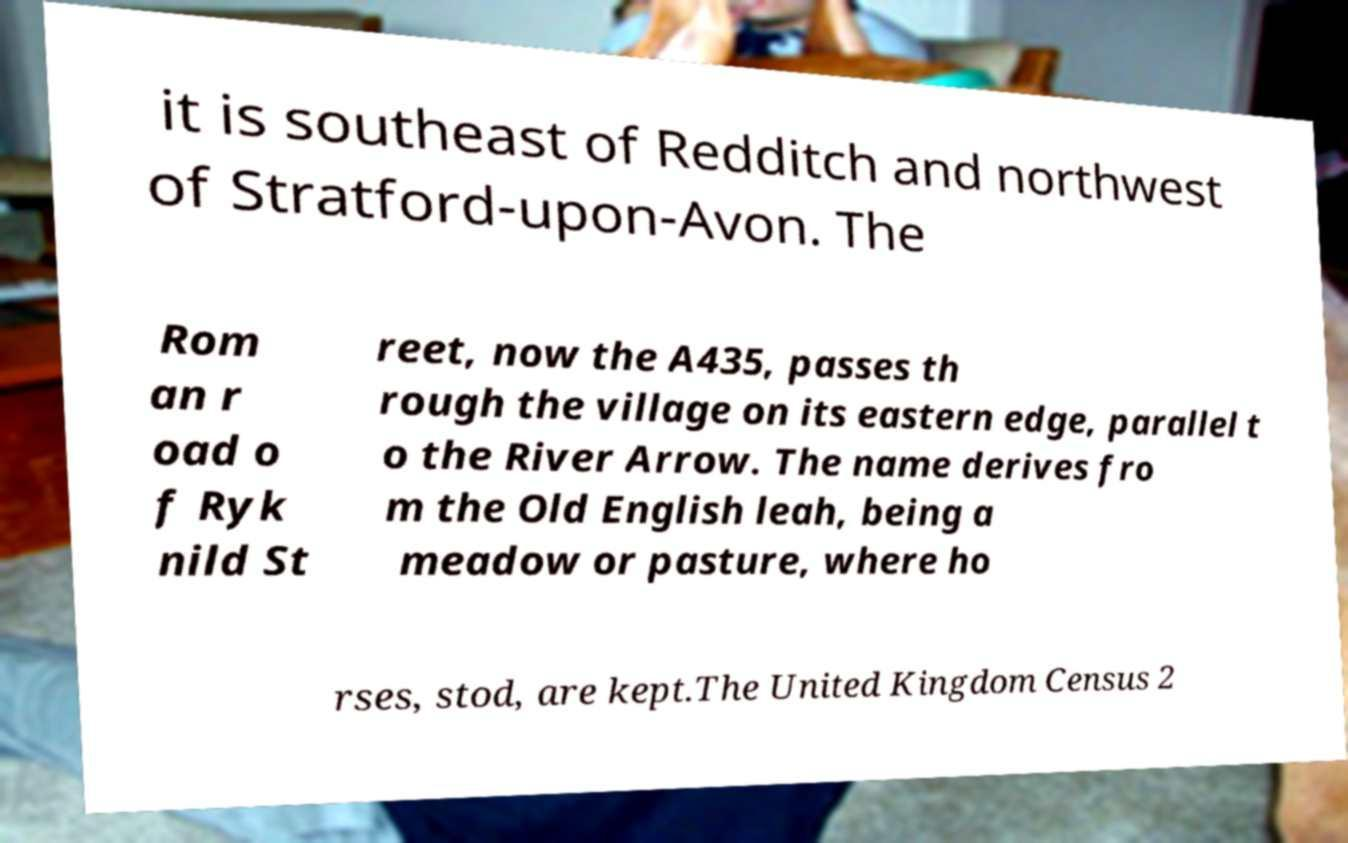Could you assist in decoding the text presented in this image and type it out clearly? it is southeast of Redditch and northwest of Stratford-upon-Avon. The Rom an r oad o f Ryk nild St reet, now the A435, passes th rough the village on its eastern edge, parallel t o the River Arrow. The name derives fro m the Old English leah, being a meadow or pasture, where ho rses, stod, are kept.The United Kingdom Census 2 